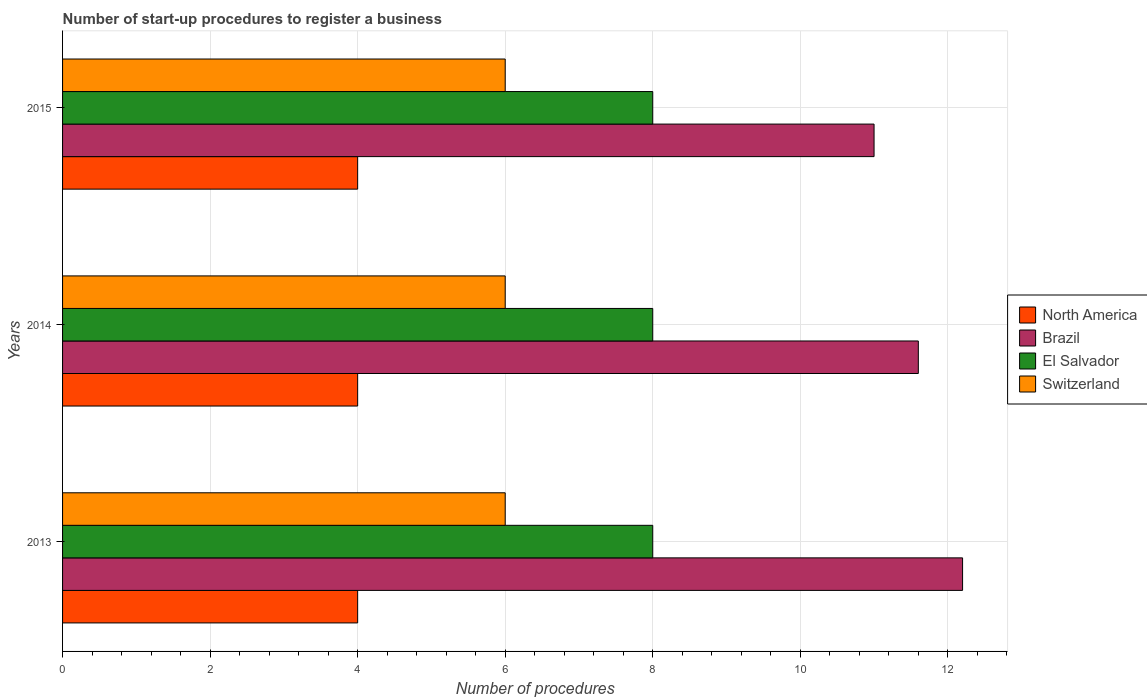How many bars are there on the 3rd tick from the top?
Keep it short and to the point. 4. How many bars are there on the 1st tick from the bottom?
Your response must be concise. 4. In how many cases, is the number of bars for a given year not equal to the number of legend labels?
Offer a very short reply. 0. Across all years, what is the minimum number of procedures required to register a business in North America?
Provide a short and direct response. 4. In which year was the number of procedures required to register a business in Brazil minimum?
Give a very brief answer. 2015. What is the total number of procedures required to register a business in Switzerland in the graph?
Ensure brevity in your answer.  18. What is the difference between the number of procedures required to register a business in Brazil in 2014 and that in 2015?
Provide a succinct answer. 0.6. What is the difference between the number of procedures required to register a business in Switzerland in 2014 and the number of procedures required to register a business in North America in 2013?
Provide a short and direct response. 2. In the year 2013, what is the difference between the number of procedures required to register a business in North America and number of procedures required to register a business in Brazil?
Your answer should be very brief. -8.2. What is the ratio of the number of procedures required to register a business in El Salvador in 2013 to that in 2014?
Give a very brief answer. 1. Is the difference between the number of procedures required to register a business in North America in 2013 and 2014 greater than the difference between the number of procedures required to register a business in Brazil in 2013 and 2014?
Offer a terse response. No. In how many years, is the number of procedures required to register a business in El Salvador greater than the average number of procedures required to register a business in El Salvador taken over all years?
Your answer should be very brief. 0. Is it the case that in every year, the sum of the number of procedures required to register a business in Brazil and number of procedures required to register a business in Switzerland is greater than the sum of number of procedures required to register a business in North America and number of procedures required to register a business in El Salvador?
Offer a very short reply. No. What does the 2nd bar from the top in 2014 represents?
Make the answer very short. El Salvador. What does the 3rd bar from the bottom in 2014 represents?
Give a very brief answer. El Salvador. How many bars are there?
Keep it short and to the point. 12. Are all the bars in the graph horizontal?
Ensure brevity in your answer.  Yes. How many years are there in the graph?
Offer a terse response. 3. What is the difference between two consecutive major ticks on the X-axis?
Keep it short and to the point. 2. How are the legend labels stacked?
Offer a very short reply. Vertical. What is the title of the graph?
Keep it short and to the point. Number of start-up procedures to register a business. Does "Mali" appear as one of the legend labels in the graph?
Provide a succinct answer. No. What is the label or title of the X-axis?
Give a very brief answer. Number of procedures. What is the Number of procedures in North America in 2013?
Provide a succinct answer. 4. What is the Number of procedures in Brazil in 2013?
Offer a very short reply. 12.2. What is the Number of procedures of Brazil in 2014?
Offer a very short reply. 11.6. What is the Number of procedures in Switzerland in 2014?
Your answer should be very brief. 6. What is the Number of procedures in North America in 2015?
Provide a short and direct response. 4. Across all years, what is the maximum Number of procedures in North America?
Make the answer very short. 4. Across all years, what is the maximum Number of procedures in El Salvador?
Offer a very short reply. 8. Across all years, what is the maximum Number of procedures of Switzerland?
Your response must be concise. 6. Across all years, what is the minimum Number of procedures in North America?
Your answer should be very brief. 4. What is the total Number of procedures in Brazil in the graph?
Provide a succinct answer. 34.8. What is the total Number of procedures in El Salvador in the graph?
Make the answer very short. 24. What is the total Number of procedures of Switzerland in the graph?
Your answer should be compact. 18. What is the difference between the Number of procedures in North America in 2013 and that in 2014?
Provide a succinct answer. 0. What is the difference between the Number of procedures in Brazil in 2014 and that in 2015?
Offer a very short reply. 0.6. What is the difference between the Number of procedures in El Salvador in 2014 and that in 2015?
Offer a terse response. 0. What is the difference between the Number of procedures of North America in 2013 and the Number of procedures of Switzerland in 2014?
Provide a succinct answer. -2. What is the difference between the Number of procedures of Brazil in 2013 and the Number of procedures of El Salvador in 2014?
Keep it short and to the point. 4.2. What is the difference between the Number of procedures of Brazil in 2014 and the Number of procedures of Switzerland in 2015?
Ensure brevity in your answer.  5.6. What is the average Number of procedures in North America per year?
Give a very brief answer. 4. What is the average Number of procedures in Brazil per year?
Provide a short and direct response. 11.6. In the year 2013, what is the difference between the Number of procedures of North America and Number of procedures of Brazil?
Offer a very short reply. -8.2. In the year 2013, what is the difference between the Number of procedures in Brazil and Number of procedures in El Salvador?
Your response must be concise. 4.2. In the year 2014, what is the difference between the Number of procedures in North America and Number of procedures in Brazil?
Provide a succinct answer. -7.6. In the year 2014, what is the difference between the Number of procedures of North America and Number of procedures of Switzerland?
Make the answer very short. -2. In the year 2014, what is the difference between the Number of procedures in Brazil and Number of procedures in El Salvador?
Give a very brief answer. 3.6. In the year 2014, what is the difference between the Number of procedures of Brazil and Number of procedures of Switzerland?
Your answer should be very brief. 5.6. In the year 2014, what is the difference between the Number of procedures of El Salvador and Number of procedures of Switzerland?
Offer a terse response. 2. In the year 2015, what is the difference between the Number of procedures in North America and Number of procedures in El Salvador?
Your response must be concise. -4. In the year 2015, what is the difference between the Number of procedures of Brazil and Number of procedures of El Salvador?
Make the answer very short. 3. What is the ratio of the Number of procedures of North America in 2013 to that in 2014?
Your answer should be compact. 1. What is the ratio of the Number of procedures of Brazil in 2013 to that in 2014?
Give a very brief answer. 1.05. What is the ratio of the Number of procedures of Switzerland in 2013 to that in 2014?
Provide a short and direct response. 1. What is the ratio of the Number of procedures of North America in 2013 to that in 2015?
Give a very brief answer. 1. What is the ratio of the Number of procedures in Brazil in 2013 to that in 2015?
Offer a terse response. 1.11. What is the ratio of the Number of procedures of North America in 2014 to that in 2015?
Offer a terse response. 1. What is the ratio of the Number of procedures in Brazil in 2014 to that in 2015?
Ensure brevity in your answer.  1.05. What is the ratio of the Number of procedures in El Salvador in 2014 to that in 2015?
Provide a short and direct response. 1. What is the ratio of the Number of procedures in Switzerland in 2014 to that in 2015?
Your answer should be compact. 1. What is the difference between the highest and the second highest Number of procedures in North America?
Your answer should be compact. 0. What is the difference between the highest and the second highest Number of procedures of Brazil?
Provide a succinct answer. 0.6. 